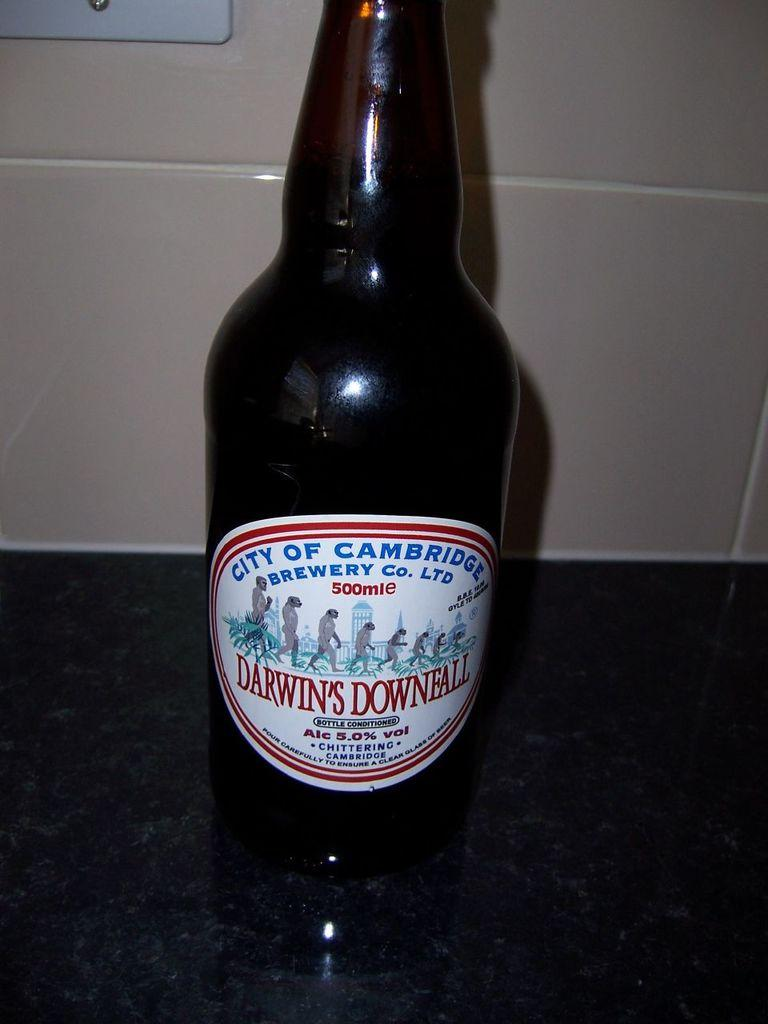<image>
Write a terse but informative summary of the picture. Beer with a white oval label with Darwin's Downfall in red lettering. 